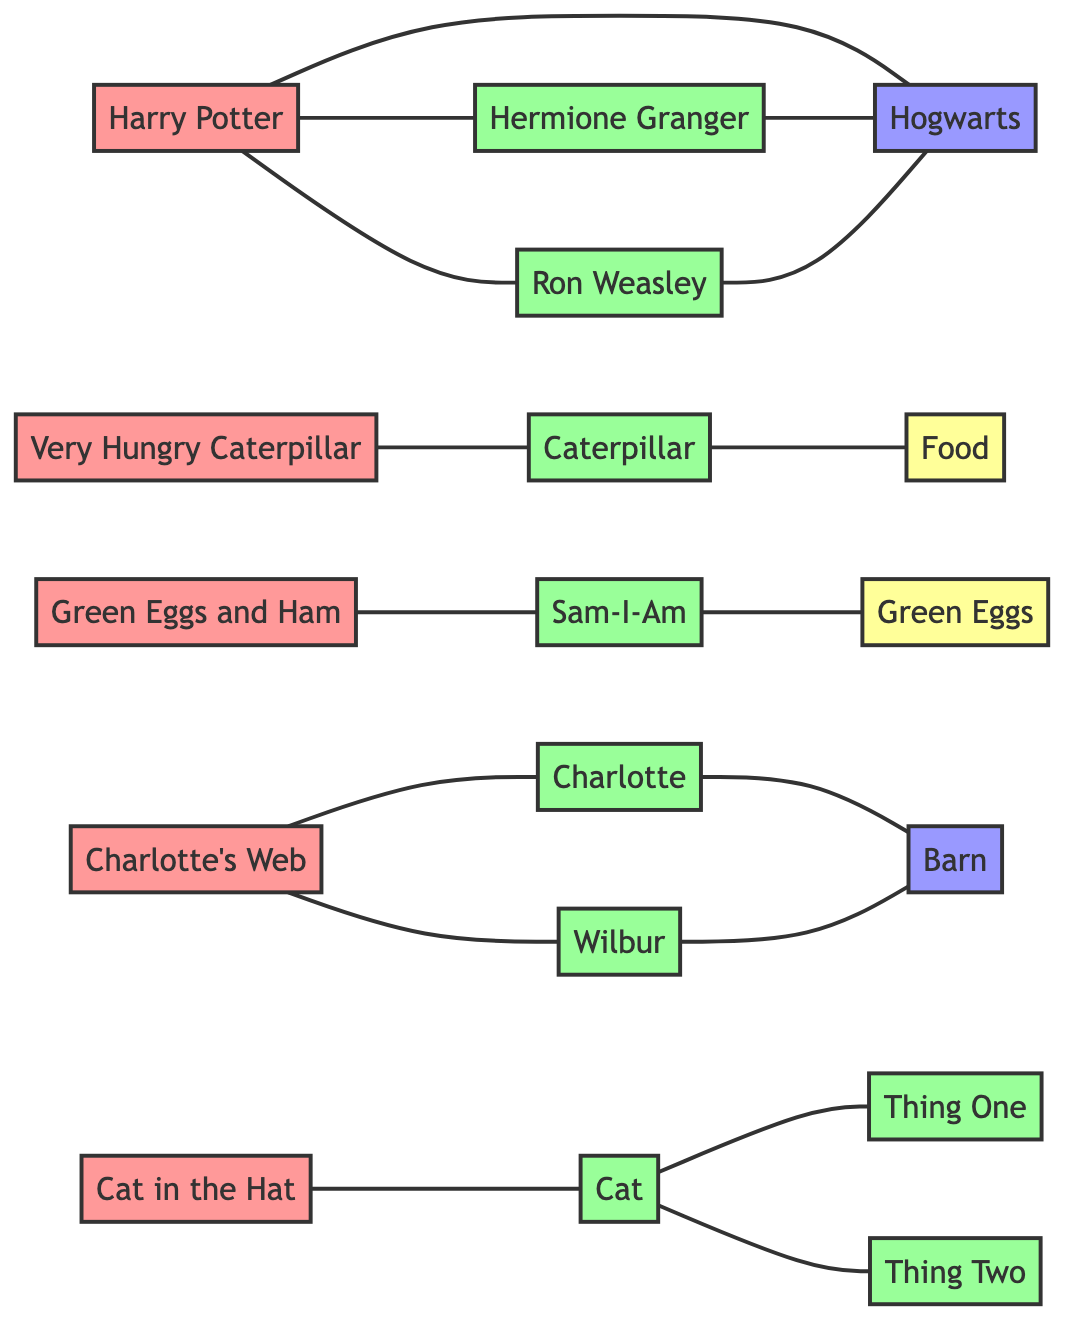What are the main characters in Harry Potter? The characters connected to Harry Potter in the diagram are Hermione Granger and Ron Weasley. They are both directly linked to Harry Potter, indicating they are main characters in the story.
Answer: Hermione Granger, Ron Weasley How many books are listed in the diagram? The books in the diagram are Harry Potter, The Very Hungry Caterpillar, Green Eggs and Ham, Charlotte's Web, and Cat in the Hat. There are five nodes in the "Books" group, which makes the total count five.
Answer: 5 Which character is connected to the Cat in the Hat? The Cat in the Hat is connected to the Cat, Thing One, and Thing Two as indicated by the lines in the diagram. The primary character is the Cat.
Answer: Cat What is the setting for Charlotte's Web? The setting of Charlotte's Web is indicated by the link to the Barn, which connects to both Charlotte and Wilbur, thus showing that the Barn is a significant location in the story.
Answer: Barn How many characters are associated with the Very Hungry Caterpillar? The character connected to the Very Hungry Caterpillar is the Caterpillar itself, which is the only link directly associated with that book, indicating there is one character.
Answer: 1 Name a food item linked to the Caterpillar. The diagram shows that the Caterpillar is connected to Food, which indicates what the character is primarily associated with or eats throughout the story of The Very Hungry Caterpillar.
Answer: Food Which character is linked with Green Eggs and Ham? Sam-I-Am is the character linked to Green Eggs and Ham according to the connections drawn in the diagram, indicating he plays a central role in that story.
Answer: Sam-I-Am How many characters are linked to Charlotte's Web? The diagram shows there are two characters linked to Charlotte's Web: Charlotte and Wilbur. They are both directly connected to this particular book.
Answer: 2 Which book has a connection to Hogwarts? The book that is connected to Hogwarts is Harry Potter, as it is directly linked to Hogwarts, indicating it is the main setting spanning across that story.
Answer: Harry Potter 